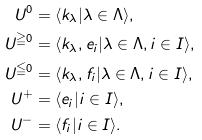<formula> <loc_0><loc_0><loc_500><loc_500>U ^ { 0 } & = \langle k _ { \lambda } | \lambda \in \Lambda \rangle , \\ U ^ { \geqq 0 } & = \langle k _ { \lambda } , e _ { i } | \lambda \in \Lambda , i \in I \rangle , \\ U ^ { \leqq 0 } & = \langle k _ { \lambda } , f _ { i } | \lambda \in \Lambda , i \in I \rangle , \\ U ^ { + } & = \langle e _ { i } | i \in I \rangle , \\ U ^ { - } & = \langle f _ { i } | i \in I \rangle .</formula> 